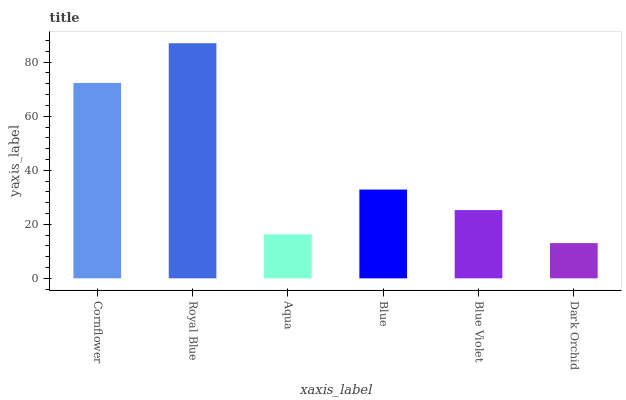Is Dark Orchid the minimum?
Answer yes or no. Yes. Is Royal Blue the maximum?
Answer yes or no. Yes. Is Aqua the minimum?
Answer yes or no. No. Is Aqua the maximum?
Answer yes or no. No. Is Royal Blue greater than Aqua?
Answer yes or no. Yes. Is Aqua less than Royal Blue?
Answer yes or no. Yes. Is Aqua greater than Royal Blue?
Answer yes or no. No. Is Royal Blue less than Aqua?
Answer yes or no. No. Is Blue the high median?
Answer yes or no. Yes. Is Blue Violet the low median?
Answer yes or no. Yes. Is Blue Violet the high median?
Answer yes or no. No. Is Cornflower the low median?
Answer yes or no. No. 